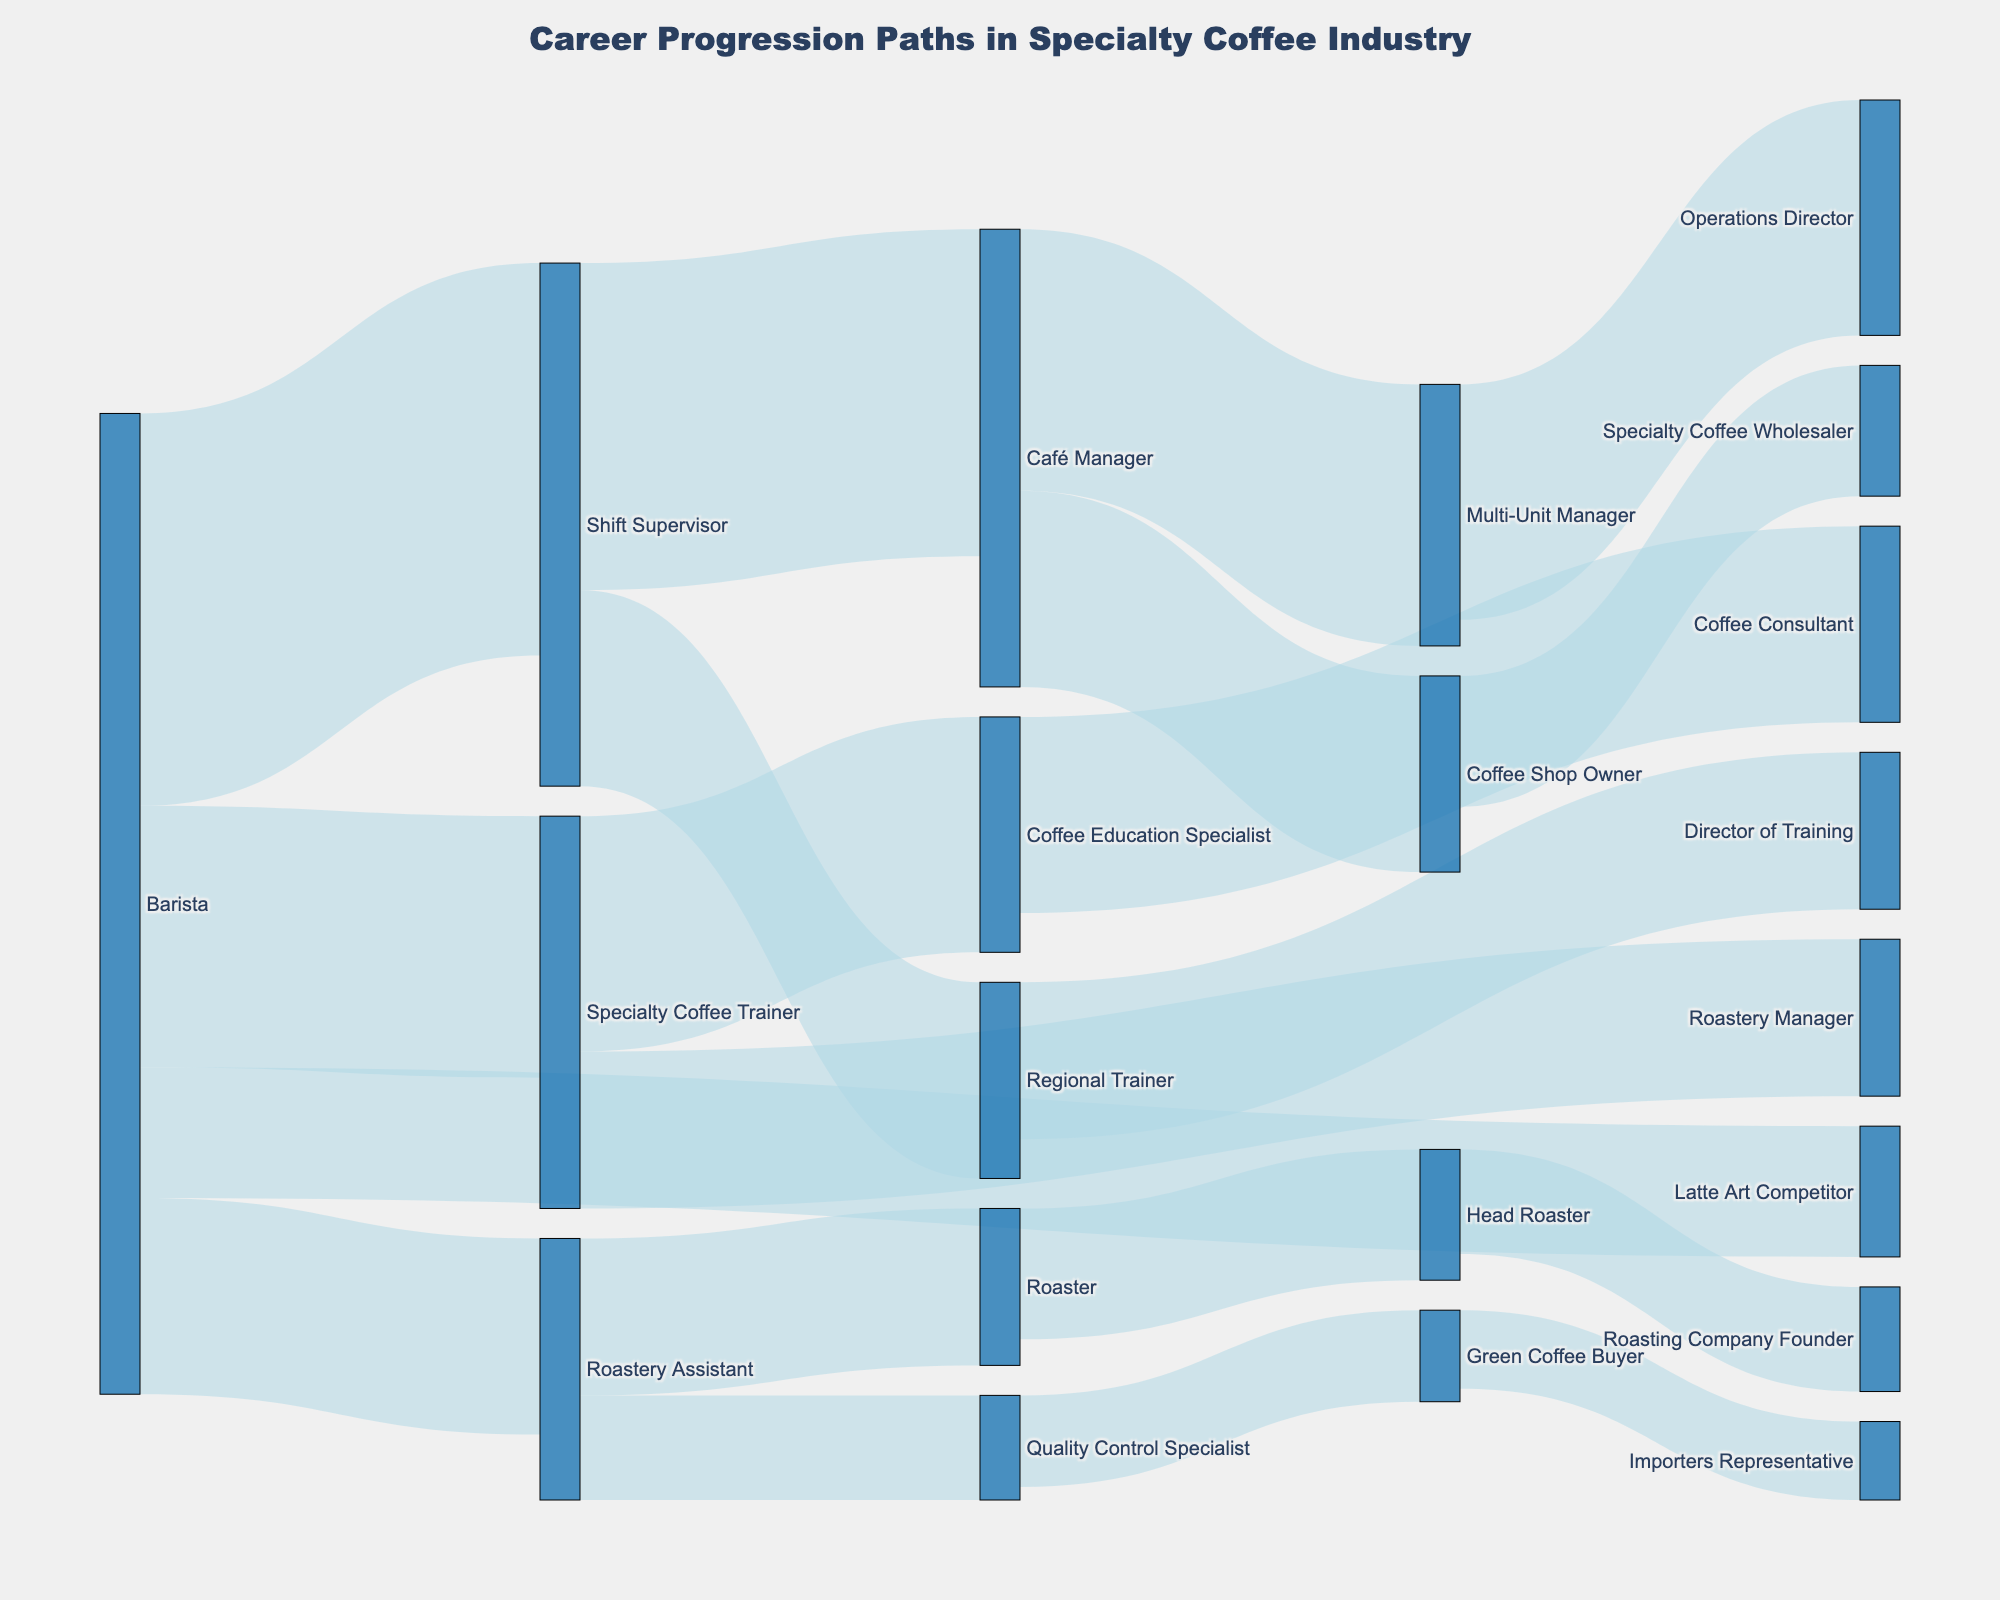What is the title of the Sankey diagram? The title of a plot is usually located at the top center. In the given Sankey diagram, the title is "Career Progression Paths in Specialty Coffee Industry".
Answer: Career Progression Paths in Specialty Coffee Industry How many career progression paths start from 'Barista'? Look for nodes that have 'Barista' as the source and count the number of connections leading out from it. There are four paths starting from 'Barista'.
Answer: 4 Which role has the most career progression options available from it? Check which node has the most outgoing connections by looking for the source nodes with the highest number of targets. The 'Barista' role has the most options with four paths originating from it.
Answer: Barista How many people transition from 'Shift Supervisor' to 'Café Manager'? Find the link labeled 'Shift Supervisor' leading to 'Café Manager' and check the value associated with it, which is 25.
Answer: 25 What is the combined number of transitions from 'Barista' to 'Shift Supervisor' and 'Barista' to 'Specialty Coffee Trainer'? Sum the values of the two transitions: 30 (Barista to Shift Supervisor) + 20 (Barista to Specialty Coffee Trainer) = 50.
Answer: 50 Which transition has the least number of people? Look at all the values associated with each link between nodes and identify the smallest value. The smallest value is 6, which is the transition from 'Green Coffee Buyer' to 'Importers Representative'.
Answer: Green Coffee Buyer to Importers Representative What is the total number of transitions involving the 'Café Manager' role? Add up all the values for links involving 'Café Manager' as either source or target. There are three links: 'Shift Supervisor' to 'Café Manager' (25), 'Café Manager' to 'Multi-Unit Manager' (20), and 'Café Manager' to 'Coffee Shop Owner' (15). Total is 25 + 20 + 15 = 60.
Answer: 60 Which career progression has more transitions: 'Roastery Assistant' to 'Roaster' or 'Specialty Coffee Trainer' to 'Roastery Manager'? Compare the number of transitions for the two paths. 'Roastery Assistant' to 'Roaster' has 12 transitions, and 'Specialty Coffee Trainer' to 'Roastery Manager' has 12 transitions. Therefore, they are equal.
Answer: Equal What is the value of the largest single career transition in the diagram? Identify the link with the highest value across the entire diagram, which is 'Barista' to 'Shift Supervisor' with a value of 30.
Answer: 30 How many career transitions end with a 'Roastery Assistant'? Identify the links for which 'Roastery Assistant' is a target and sum their values. Only one path leads to 'Roastery Assistant' (from 'Barista'), with a value of 15.
Answer: 15 